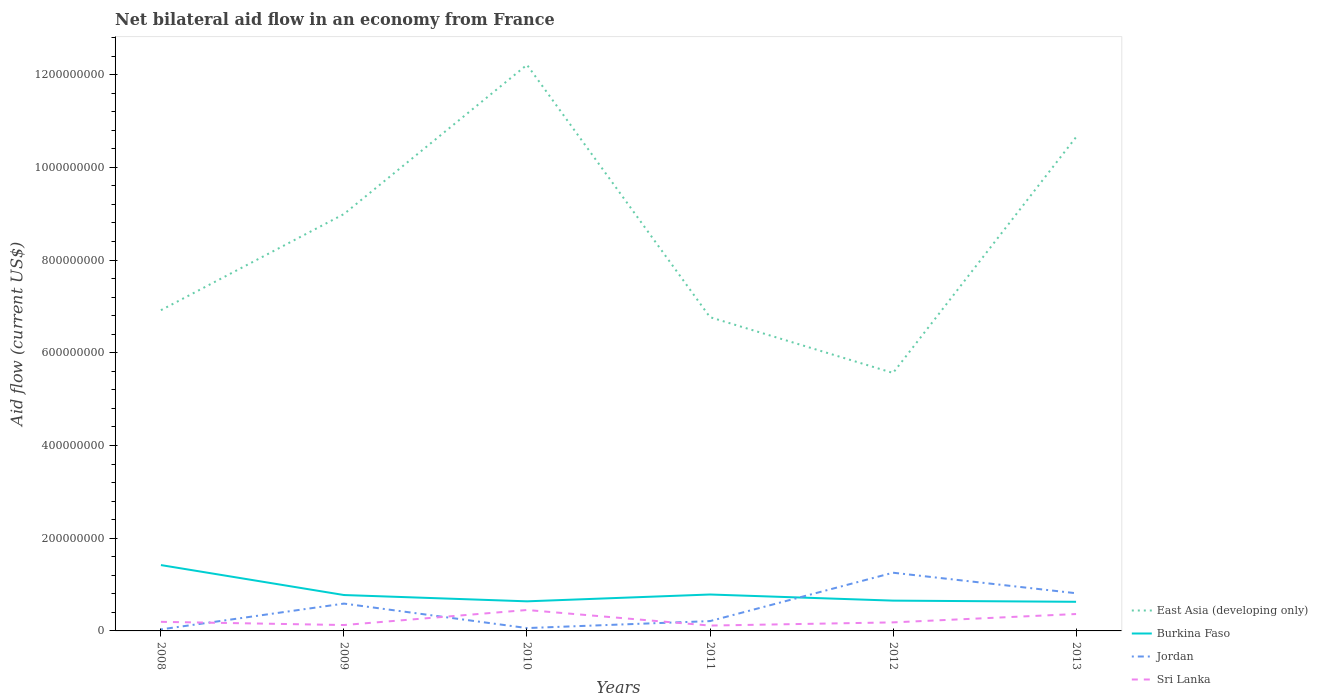Is the number of lines equal to the number of legend labels?
Offer a terse response. Yes. Across all years, what is the maximum net bilateral aid flow in East Asia (developing only)?
Offer a terse response. 5.56e+08. What is the total net bilateral aid flow in East Asia (developing only) in the graph?
Give a very brief answer. -5.29e+08. What is the difference between the highest and the second highest net bilateral aid flow in Sri Lanka?
Your answer should be very brief. 3.36e+07. What is the difference between two consecutive major ticks on the Y-axis?
Provide a succinct answer. 2.00e+08. Are the values on the major ticks of Y-axis written in scientific E-notation?
Your answer should be very brief. No. What is the title of the graph?
Provide a succinct answer. Net bilateral aid flow in an economy from France. Does "Kenya" appear as one of the legend labels in the graph?
Offer a terse response. No. What is the label or title of the Y-axis?
Provide a succinct answer. Aid flow (current US$). What is the Aid flow (current US$) of East Asia (developing only) in 2008?
Offer a terse response. 6.92e+08. What is the Aid flow (current US$) of Burkina Faso in 2008?
Give a very brief answer. 1.42e+08. What is the Aid flow (current US$) in Jordan in 2008?
Keep it short and to the point. 3.32e+06. What is the Aid flow (current US$) in Sri Lanka in 2008?
Make the answer very short. 1.96e+07. What is the Aid flow (current US$) of East Asia (developing only) in 2009?
Provide a short and direct response. 8.99e+08. What is the Aid flow (current US$) in Burkina Faso in 2009?
Offer a very short reply. 7.74e+07. What is the Aid flow (current US$) in Jordan in 2009?
Provide a short and direct response. 5.89e+07. What is the Aid flow (current US$) of Sri Lanka in 2009?
Provide a short and direct response. 1.27e+07. What is the Aid flow (current US$) of East Asia (developing only) in 2010?
Keep it short and to the point. 1.22e+09. What is the Aid flow (current US$) of Burkina Faso in 2010?
Your answer should be very brief. 6.38e+07. What is the Aid flow (current US$) of Jordan in 2010?
Give a very brief answer. 6.16e+06. What is the Aid flow (current US$) of Sri Lanka in 2010?
Offer a terse response. 4.51e+07. What is the Aid flow (current US$) in East Asia (developing only) in 2011?
Give a very brief answer. 6.77e+08. What is the Aid flow (current US$) in Burkina Faso in 2011?
Provide a short and direct response. 7.85e+07. What is the Aid flow (current US$) of Jordan in 2011?
Provide a succinct answer. 2.12e+07. What is the Aid flow (current US$) in Sri Lanka in 2011?
Your answer should be very brief. 1.15e+07. What is the Aid flow (current US$) in East Asia (developing only) in 2012?
Keep it short and to the point. 5.56e+08. What is the Aid flow (current US$) in Burkina Faso in 2012?
Your response must be concise. 6.53e+07. What is the Aid flow (current US$) of Jordan in 2012?
Make the answer very short. 1.26e+08. What is the Aid flow (current US$) of Sri Lanka in 2012?
Offer a very short reply. 1.84e+07. What is the Aid flow (current US$) of East Asia (developing only) in 2013?
Your answer should be compact. 1.07e+09. What is the Aid flow (current US$) of Burkina Faso in 2013?
Your answer should be very brief. 6.28e+07. What is the Aid flow (current US$) in Jordan in 2013?
Provide a short and direct response. 8.13e+07. What is the Aid flow (current US$) of Sri Lanka in 2013?
Provide a succinct answer. 3.64e+07. Across all years, what is the maximum Aid flow (current US$) in East Asia (developing only)?
Your response must be concise. 1.22e+09. Across all years, what is the maximum Aid flow (current US$) in Burkina Faso?
Ensure brevity in your answer.  1.42e+08. Across all years, what is the maximum Aid flow (current US$) of Jordan?
Your answer should be compact. 1.26e+08. Across all years, what is the maximum Aid flow (current US$) in Sri Lanka?
Your answer should be compact. 4.51e+07. Across all years, what is the minimum Aid flow (current US$) of East Asia (developing only)?
Provide a succinct answer. 5.56e+08. Across all years, what is the minimum Aid flow (current US$) of Burkina Faso?
Keep it short and to the point. 6.28e+07. Across all years, what is the minimum Aid flow (current US$) of Jordan?
Your response must be concise. 3.32e+06. Across all years, what is the minimum Aid flow (current US$) of Sri Lanka?
Offer a terse response. 1.15e+07. What is the total Aid flow (current US$) in East Asia (developing only) in the graph?
Provide a short and direct response. 5.11e+09. What is the total Aid flow (current US$) of Burkina Faso in the graph?
Your answer should be compact. 4.90e+08. What is the total Aid flow (current US$) in Jordan in the graph?
Provide a succinct answer. 2.96e+08. What is the total Aid flow (current US$) in Sri Lanka in the graph?
Provide a short and direct response. 1.44e+08. What is the difference between the Aid flow (current US$) in East Asia (developing only) in 2008 and that in 2009?
Provide a short and direct response. -2.07e+08. What is the difference between the Aid flow (current US$) in Burkina Faso in 2008 and that in 2009?
Offer a terse response. 6.46e+07. What is the difference between the Aid flow (current US$) in Jordan in 2008 and that in 2009?
Your answer should be very brief. -5.56e+07. What is the difference between the Aid flow (current US$) in Sri Lanka in 2008 and that in 2009?
Give a very brief answer. 6.92e+06. What is the difference between the Aid flow (current US$) in East Asia (developing only) in 2008 and that in 2010?
Ensure brevity in your answer.  -5.29e+08. What is the difference between the Aid flow (current US$) in Burkina Faso in 2008 and that in 2010?
Make the answer very short. 7.82e+07. What is the difference between the Aid flow (current US$) in Jordan in 2008 and that in 2010?
Provide a short and direct response. -2.84e+06. What is the difference between the Aid flow (current US$) of Sri Lanka in 2008 and that in 2010?
Give a very brief answer. -2.55e+07. What is the difference between the Aid flow (current US$) of East Asia (developing only) in 2008 and that in 2011?
Provide a succinct answer. 1.51e+07. What is the difference between the Aid flow (current US$) in Burkina Faso in 2008 and that in 2011?
Provide a succinct answer. 6.35e+07. What is the difference between the Aid flow (current US$) of Jordan in 2008 and that in 2011?
Keep it short and to the point. -1.79e+07. What is the difference between the Aid flow (current US$) of Sri Lanka in 2008 and that in 2011?
Your response must be concise. 8.07e+06. What is the difference between the Aid flow (current US$) of East Asia (developing only) in 2008 and that in 2012?
Offer a very short reply. 1.35e+08. What is the difference between the Aid flow (current US$) of Burkina Faso in 2008 and that in 2012?
Offer a terse response. 7.67e+07. What is the difference between the Aid flow (current US$) of Jordan in 2008 and that in 2012?
Your response must be concise. -1.22e+08. What is the difference between the Aid flow (current US$) in Sri Lanka in 2008 and that in 2012?
Offer a terse response. 1.19e+06. What is the difference between the Aid flow (current US$) of East Asia (developing only) in 2008 and that in 2013?
Make the answer very short. -3.73e+08. What is the difference between the Aid flow (current US$) in Burkina Faso in 2008 and that in 2013?
Ensure brevity in your answer.  7.92e+07. What is the difference between the Aid flow (current US$) in Jordan in 2008 and that in 2013?
Your response must be concise. -7.80e+07. What is the difference between the Aid flow (current US$) of Sri Lanka in 2008 and that in 2013?
Give a very brief answer. -1.68e+07. What is the difference between the Aid flow (current US$) of East Asia (developing only) in 2009 and that in 2010?
Provide a succinct answer. -3.22e+08. What is the difference between the Aid flow (current US$) in Burkina Faso in 2009 and that in 2010?
Your answer should be compact. 1.36e+07. What is the difference between the Aid flow (current US$) of Jordan in 2009 and that in 2010?
Make the answer very short. 5.28e+07. What is the difference between the Aid flow (current US$) of Sri Lanka in 2009 and that in 2010?
Provide a short and direct response. -3.24e+07. What is the difference between the Aid flow (current US$) of East Asia (developing only) in 2009 and that in 2011?
Make the answer very short. 2.22e+08. What is the difference between the Aid flow (current US$) of Burkina Faso in 2009 and that in 2011?
Keep it short and to the point. -1.12e+06. What is the difference between the Aid flow (current US$) in Jordan in 2009 and that in 2011?
Your response must be concise. 3.78e+07. What is the difference between the Aid flow (current US$) in Sri Lanka in 2009 and that in 2011?
Give a very brief answer. 1.15e+06. What is the difference between the Aid flow (current US$) in East Asia (developing only) in 2009 and that in 2012?
Ensure brevity in your answer.  3.43e+08. What is the difference between the Aid flow (current US$) in Burkina Faso in 2009 and that in 2012?
Offer a very short reply. 1.21e+07. What is the difference between the Aid flow (current US$) of Jordan in 2009 and that in 2012?
Offer a terse response. -6.66e+07. What is the difference between the Aid flow (current US$) of Sri Lanka in 2009 and that in 2012?
Make the answer very short. -5.73e+06. What is the difference between the Aid flow (current US$) in East Asia (developing only) in 2009 and that in 2013?
Offer a terse response. -1.66e+08. What is the difference between the Aid flow (current US$) in Burkina Faso in 2009 and that in 2013?
Your response must be concise. 1.46e+07. What is the difference between the Aid flow (current US$) of Jordan in 2009 and that in 2013?
Ensure brevity in your answer.  -2.24e+07. What is the difference between the Aid flow (current US$) in Sri Lanka in 2009 and that in 2013?
Make the answer very short. -2.38e+07. What is the difference between the Aid flow (current US$) of East Asia (developing only) in 2010 and that in 2011?
Provide a short and direct response. 5.44e+08. What is the difference between the Aid flow (current US$) in Burkina Faso in 2010 and that in 2011?
Your answer should be compact. -1.47e+07. What is the difference between the Aid flow (current US$) of Jordan in 2010 and that in 2011?
Offer a very short reply. -1.50e+07. What is the difference between the Aid flow (current US$) in Sri Lanka in 2010 and that in 2011?
Provide a succinct answer. 3.36e+07. What is the difference between the Aid flow (current US$) of East Asia (developing only) in 2010 and that in 2012?
Provide a short and direct response. 6.65e+08. What is the difference between the Aid flow (current US$) of Burkina Faso in 2010 and that in 2012?
Your answer should be compact. -1.51e+06. What is the difference between the Aid flow (current US$) in Jordan in 2010 and that in 2012?
Your answer should be very brief. -1.19e+08. What is the difference between the Aid flow (current US$) in Sri Lanka in 2010 and that in 2012?
Keep it short and to the point. 2.67e+07. What is the difference between the Aid flow (current US$) in East Asia (developing only) in 2010 and that in 2013?
Your response must be concise. 1.56e+08. What is the difference between the Aid flow (current US$) in Burkina Faso in 2010 and that in 2013?
Your answer should be very brief. 1.01e+06. What is the difference between the Aid flow (current US$) of Jordan in 2010 and that in 2013?
Make the answer very short. -7.51e+07. What is the difference between the Aid flow (current US$) of Sri Lanka in 2010 and that in 2013?
Provide a succinct answer. 8.69e+06. What is the difference between the Aid flow (current US$) of East Asia (developing only) in 2011 and that in 2012?
Give a very brief answer. 1.20e+08. What is the difference between the Aid flow (current US$) of Burkina Faso in 2011 and that in 2012?
Ensure brevity in your answer.  1.32e+07. What is the difference between the Aid flow (current US$) in Jordan in 2011 and that in 2012?
Make the answer very short. -1.04e+08. What is the difference between the Aid flow (current US$) in Sri Lanka in 2011 and that in 2012?
Provide a succinct answer. -6.88e+06. What is the difference between the Aid flow (current US$) of East Asia (developing only) in 2011 and that in 2013?
Your response must be concise. -3.88e+08. What is the difference between the Aid flow (current US$) in Burkina Faso in 2011 and that in 2013?
Offer a terse response. 1.57e+07. What is the difference between the Aid flow (current US$) of Jordan in 2011 and that in 2013?
Provide a short and direct response. -6.01e+07. What is the difference between the Aid flow (current US$) in Sri Lanka in 2011 and that in 2013?
Give a very brief answer. -2.49e+07. What is the difference between the Aid flow (current US$) of East Asia (developing only) in 2012 and that in 2013?
Your answer should be very brief. -5.09e+08. What is the difference between the Aid flow (current US$) of Burkina Faso in 2012 and that in 2013?
Ensure brevity in your answer.  2.52e+06. What is the difference between the Aid flow (current US$) of Jordan in 2012 and that in 2013?
Provide a short and direct response. 4.42e+07. What is the difference between the Aid flow (current US$) of Sri Lanka in 2012 and that in 2013?
Your answer should be compact. -1.80e+07. What is the difference between the Aid flow (current US$) in East Asia (developing only) in 2008 and the Aid flow (current US$) in Burkina Faso in 2009?
Ensure brevity in your answer.  6.14e+08. What is the difference between the Aid flow (current US$) of East Asia (developing only) in 2008 and the Aid flow (current US$) of Jordan in 2009?
Your answer should be compact. 6.33e+08. What is the difference between the Aid flow (current US$) in East Asia (developing only) in 2008 and the Aid flow (current US$) in Sri Lanka in 2009?
Offer a very short reply. 6.79e+08. What is the difference between the Aid flow (current US$) in Burkina Faso in 2008 and the Aid flow (current US$) in Jordan in 2009?
Make the answer very short. 8.31e+07. What is the difference between the Aid flow (current US$) in Burkina Faso in 2008 and the Aid flow (current US$) in Sri Lanka in 2009?
Provide a short and direct response. 1.29e+08. What is the difference between the Aid flow (current US$) in Jordan in 2008 and the Aid flow (current US$) in Sri Lanka in 2009?
Ensure brevity in your answer.  -9.37e+06. What is the difference between the Aid flow (current US$) in East Asia (developing only) in 2008 and the Aid flow (current US$) in Burkina Faso in 2010?
Your answer should be very brief. 6.28e+08. What is the difference between the Aid flow (current US$) of East Asia (developing only) in 2008 and the Aid flow (current US$) of Jordan in 2010?
Provide a short and direct response. 6.86e+08. What is the difference between the Aid flow (current US$) in East Asia (developing only) in 2008 and the Aid flow (current US$) in Sri Lanka in 2010?
Make the answer very short. 6.47e+08. What is the difference between the Aid flow (current US$) of Burkina Faso in 2008 and the Aid flow (current US$) of Jordan in 2010?
Your answer should be compact. 1.36e+08. What is the difference between the Aid flow (current US$) in Burkina Faso in 2008 and the Aid flow (current US$) in Sri Lanka in 2010?
Your response must be concise. 9.69e+07. What is the difference between the Aid flow (current US$) of Jordan in 2008 and the Aid flow (current US$) of Sri Lanka in 2010?
Ensure brevity in your answer.  -4.18e+07. What is the difference between the Aid flow (current US$) in East Asia (developing only) in 2008 and the Aid flow (current US$) in Burkina Faso in 2011?
Make the answer very short. 6.13e+08. What is the difference between the Aid flow (current US$) in East Asia (developing only) in 2008 and the Aid flow (current US$) in Jordan in 2011?
Offer a terse response. 6.71e+08. What is the difference between the Aid flow (current US$) of East Asia (developing only) in 2008 and the Aid flow (current US$) of Sri Lanka in 2011?
Your response must be concise. 6.80e+08. What is the difference between the Aid flow (current US$) of Burkina Faso in 2008 and the Aid flow (current US$) of Jordan in 2011?
Offer a terse response. 1.21e+08. What is the difference between the Aid flow (current US$) in Burkina Faso in 2008 and the Aid flow (current US$) in Sri Lanka in 2011?
Give a very brief answer. 1.30e+08. What is the difference between the Aid flow (current US$) of Jordan in 2008 and the Aid flow (current US$) of Sri Lanka in 2011?
Your answer should be very brief. -8.22e+06. What is the difference between the Aid flow (current US$) of East Asia (developing only) in 2008 and the Aid flow (current US$) of Burkina Faso in 2012?
Provide a short and direct response. 6.26e+08. What is the difference between the Aid flow (current US$) in East Asia (developing only) in 2008 and the Aid flow (current US$) in Jordan in 2012?
Offer a very short reply. 5.66e+08. What is the difference between the Aid flow (current US$) in East Asia (developing only) in 2008 and the Aid flow (current US$) in Sri Lanka in 2012?
Your answer should be compact. 6.73e+08. What is the difference between the Aid flow (current US$) of Burkina Faso in 2008 and the Aid flow (current US$) of Jordan in 2012?
Ensure brevity in your answer.  1.65e+07. What is the difference between the Aid flow (current US$) of Burkina Faso in 2008 and the Aid flow (current US$) of Sri Lanka in 2012?
Keep it short and to the point. 1.24e+08. What is the difference between the Aid flow (current US$) in Jordan in 2008 and the Aid flow (current US$) in Sri Lanka in 2012?
Make the answer very short. -1.51e+07. What is the difference between the Aid flow (current US$) of East Asia (developing only) in 2008 and the Aid flow (current US$) of Burkina Faso in 2013?
Provide a short and direct response. 6.29e+08. What is the difference between the Aid flow (current US$) in East Asia (developing only) in 2008 and the Aid flow (current US$) in Jordan in 2013?
Give a very brief answer. 6.10e+08. What is the difference between the Aid flow (current US$) in East Asia (developing only) in 2008 and the Aid flow (current US$) in Sri Lanka in 2013?
Ensure brevity in your answer.  6.55e+08. What is the difference between the Aid flow (current US$) of Burkina Faso in 2008 and the Aid flow (current US$) of Jordan in 2013?
Give a very brief answer. 6.07e+07. What is the difference between the Aid flow (current US$) in Burkina Faso in 2008 and the Aid flow (current US$) in Sri Lanka in 2013?
Ensure brevity in your answer.  1.06e+08. What is the difference between the Aid flow (current US$) of Jordan in 2008 and the Aid flow (current US$) of Sri Lanka in 2013?
Offer a terse response. -3.31e+07. What is the difference between the Aid flow (current US$) of East Asia (developing only) in 2009 and the Aid flow (current US$) of Burkina Faso in 2010?
Offer a very short reply. 8.35e+08. What is the difference between the Aid flow (current US$) of East Asia (developing only) in 2009 and the Aid flow (current US$) of Jordan in 2010?
Your answer should be very brief. 8.93e+08. What is the difference between the Aid flow (current US$) of East Asia (developing only) in 2009 and the Aid flow (current US$) of Sri Lanka in 2010?
Offer a very short reply. 8.54e+08. What is the difference between the Aid flow (current US$) of Burkina Faso in 2009 and the Aid flow (current US$) of Jordan in 2010?
Make the answer very short. 7.13e+07. What is the difference between the Aid flow (current US$) of Burkina Faso in 2009 and the Aid flow (current US$) of Sri Lanka in 2010?
Give a very brief answer. 3.23e+07. What is the difference between the Aid flow (current US$) in Jordan in 2009 and the Aid flow (current US$) in Sri Lanka in 2010?
Offer a very short reply. 1.38e+07. What is the difference between the Aid flow (current US$) of East Asia (developing only) in 2009 and the Aid flow (current US$) of Burkina Faso in 2011?
Offer a very short reply. 8.21e+08. What is the difference between the Aid flow (current US$) of East Asia (developing only) in 2009 and the Aid flow (current US$) of Jordan in 2011?
Provide a short and direct response. 8.78e+08. What is the difference between the Aid flow (current US$) of East Asia (developing only) in 2009 and the Aid flow (current US$) of Sri Lanka in 2011?
Ensure brevity in your answer.  8.88e+08. What is the difference between the Aid flow (current US$) of Burkina Faso in 2009 and the Aid flow (current US$) of Jordan in 2011?
Keep it short and to the point. 5.62e+07. What is the difference between the Aid flow (current US$) in Burkina Faso in 2009 and the Aid flow (current US$) in Sri Lanka in 2011?
Give a very brief answer. 6.59e+07. What is the difference between the Aid flow (current US$) in Jordan in 2009 and the Aid flow (current US$) in Sri Lanka in 2011?
Your response must be concise. 4.74e+07. What is the difference between the Aid flow (current US$) in East Asia (developing only) in 2009 and the Aid flow (current US$) in Burkina Faso in 2012?
Ensure brevity in your answer.  8.34e+08. What is the difference between the Aid flow (current US$) of East Asia (developing only) in 2009 and the Aid flow (current US$) of Jordan in 2012?
Provide a short and direct response. 7.74e+08. What is the difference between the Aid flow (current US$) of East Asia (developing only) in 2009 and the Aid flow (current US$) of Sri Lanka in 2012?
Give a very brief answer. 8.81e+08. What is the difference between the Aid flow (current US$) in Burkina Faso in 2009 and the Aid flow (current US$) in Jordan in 2012?
Keep it short and to the point. -4.81e+07. What is the difference between the Aid flow (current US$) of Burkina Faso in 2009 and the Aid flow (current US$) of Sri Lanka in 2012?
Give a very brief answer. 5.90e+07. What is the difference between the Aid flow (current US$) of Jordan in 2009 and the Aid flow (current US$) of Sri Lanka in 2012?
Give a very brief answer. 4.05e+07. What is the difference between the Aid flow (current US$) in East Asia (developing only) in 2009 and the Aid flow (current US$) in Burkina Faso in 2013?
Your response must be concise. 8.36e+08. What is the difference between the Aid flow (current US$) of East Asia (developing only) in 2009 and the Aid flow (current US$) of Jordan in 2013?
Provide a short and direct response. 8.18e+08. What is the difference between the Aid flow (current US$) of East Asia (developing only) in 2009 and the Aid flow (current US$) of Sri Lanka in 2013?
Offer a very short reply. 8.63e+08. What is the difference between the Aid flow (current US$) in Burkina Faso in 2009 and the Aid flow (current US$) in Jordan in 2013?
Provide a succinct answer. -3.87e+06. What is the difference between the Aid flow (current US$) of Burkina Faso in 2009 and the Aid flow (current US$) of Sri Lanka in 2013?
Give a very brief answer. 4.10e+07. What is the difference between the Aid flow (current US$) of Jordan in 2009 and the Aid flow (current US$) of Sri Lanka in 2013?
Keep it short and to the point. 2.25e+07. What is the difference between the Aid flow (current US$) of East Asia (developing only) in 2010 and the Aid flow (current US$) of Burkina Faso in 2011?
Your response must be concise. 1.14e+09. What is the difference between the Aid flow (current US$) in East Asia (developing only) in 2010 and the Aid flow (current US$) in Jordan in 2011?
Provide a succinct answer. 1.20e+09. What is the difference between the Aid flow (current US$) of East Asia (developing only) in 2010 and the Aid flow (current US$) of Sri Lanka in 2011?
Your response must be concise. 1.21e+09. What is the difference between the Aid flow (current US$) in Burkina Faso in 2010 and the Aid flow (current US$) in Jordan in 2011?
Offer a terse response. 4.26e+07. What is the difference between the Aid flow (current US$) in Burkina Faso in 2010 and the Aid flow (current US$) in Sri Lanka in 2011?
Keep it short and to the point. 5.23e+07. What is the difference between the Aid flow (current US$) in Jordan in 2010 and the Aid flow (current US$) in Sri Lanka in 2011?
Give a very brief answer. -5.38e+06. What is the difference between the Aid flow (current US$) of East Asia (developing only) in 2010 and the Aid flow (current US$) of Burkina Faso in 2012?
Your answer should be compact. 1.16e+09. What is the difference between the Aid flow (current US$) of East Asia (developing only) in 2010 and the Aid flow (current US$) of Jordan in 2012?
Provide a succinct answer. 1.10e+09. What is the difference between the Aid flow (current US$) of East Asia (developing only) in 2010 and the Aid flow (current US$) of Sri Lanka in 2012?
Your answer should be compact. 1.20e+09. What is the difference between the Aid flow (current US$) in Burkina Faso in 2010 and the Aid flow (current US$) in Jordan in 2012?
Give a very brief answer. -6.17e+07. What is the difference between the Aid flow (current US$) of Burkina Faso in 2010 and the Aid flow (current US$) of Sri Lanka in 2012?
Your response must be concise. 4.54e+07. What is the difference between the Aid flow (current US$) of Jordan in 2010 and the Aid flow (current US$) of Sri Lanka in 2012?
Your response must be concise. -1.23e+07. What is the difference between the Aid flow (current US$) in East Asia (developing only) in 2010 and the Aid flow (current US$) in Burkina Faso in 2013?
Your answer should be very brief. 1.16e+09. What is the difference between the Aid flow (current US$) in East Asia (developing only) in 2010 and the Aid flow (current US$) in Jordan in 2013?
Offer a very short reply. 1.14e+09. What is the difference between the Aid flow (current US$) in East Asia (developing only) in 2010 and the Aid flow (current US$) in Sri Lanka in 2013?
Keep it short and to the point. 1.18e+09. What is the difference between the Aid flow (current US$) in Burkina Faso in 2010 and the Aid flow (current US$) in Jordan in 2013?
Offer a terse response. -1.75e+07. What is the difference between the Aid flow (current US$) in Burkina Faso in 2010 and the Aid flow (current US$) in Sri Lanka in 2013?
Keep it short and to the point. 2.74e+07. What is the difference between the Aid flow (current US$) in Jordan in 2010 and the Aid flow (current US$) in Sri Lanka in 2013?
Offer a terse response. -3.03e+07. What is the difference between the Aid flow (current US$) of East Asia (developing only) in 2011 and the Aid flow (current US$) of Burkina Faso in 2012?
Make the answer very short. 6.11e+08. What is the difference between the Aid flow (current US$) in East Asia (developing only) in 2011 and the Aid flow (current US$) in Jordan in 2012?
Ensure brevity in your answer.  5.51e+08. What is the difference between the Aid flow (current US$) of East Asia (developing only) in 2011 and the Aid flow (current US$) of Sri Lanka in 2012?
Your response must be concise. 6.58e+08. What is the difference between the Aid flow (current US$) in Burkina Faso in 2011 and the Aid flow (current US$) in Jordan in 2012?
Your answer should be very brief. -4.70e+07. What is the difference between the Aid flow (current US$) of Burkina Faso in 2011 and the Aid flow (current US$) of Sri Lanka in 2012?
Your answer should be very brief. 6.01e+07. What is the difference between the Aid flow (current US$) in Jordan in 2011 and the Aid flow (current US$) in Sri Lanka in 2012?
Provide a succinct answer. 2.76e+06. What is the difference between the Aid flow (current US$) in East Asia (developing only) in 2011 and the Aid flow (current US$) in Burkina Faso in 2013?
Your answer should be compact. 6.14e+08. What is the difference between the Aid flow (current US$) of East Asia (developing only) in 2011 and the Aid flow (current US$) of Jordan in 2013?
Offer a very short reply. 5.95e+08. What is the difference between the Aid flow (current US$) in East Asia (developing only) in 2011 and the Aid flow (current US$) in Sri Lanka in 2013?
Make the answer very short. 6.40e+08. What is the difference between the Aid flow (current US$) in Burkina Faso in 2011 and the Aid flow (current US$) in Jordan in 2013?
Your answer should be very brief. -2.75e+06. What is the difference between the Aid flow (current US$) of Burkina Faso in 2011 and the Aid flow (current US$) of Sri Lanka in 2013?
Your response must be concise. 4.21e+07. What is the difference between the Aid flow (current US$) of Jordan in 2011 and the Aid flow (current US$) of Sri Lanka in 2013?
Offer a very short reply. -1.53e+07. What is the difference between the Aid flow (current US$) of East Asia (developing only) in 2012 and the Aid flow (current US$) of Burkina Faso in 2013?
Make the answer very short. 4.94e+08. What is the difference between the Aid flow (current US$) of East Asia (developing only) in 2012 and the Aid flow (current US$) of Jordan in 2013?
Your response must be concise. 4.75e+08. What is the difference between the Aid flow (current US$) in East Asia (developing only) in 2012 and the Aid flow (current US$) in Sri Lanka in 2013?
Provide a short and direct response. 5.20e+08. What is the difference between the Aid flow (current US$) in Burkina Faso in 2012 and the Aid flow (current US$) in Jordan in 2013?
Give a very brief answer. -1.60e+07. What is the difference between the Aid flow (current US$) of Burkina Faso in 2012 and the Aid flow (current US$) of Sri Lanka in 2013?
Make the answer very short. 2.89e+07. What is the difference between the Aid flow (current US$) of Jordan in 2012 and the Aid flow (current US$) of Sri Lanka in 2013?
Provide a succinct answer. 8.91e+07. What is the average Aid flow (current US$) of East Asia (developing only) per year?
Give a very brief answer. 8.52e+08. What is the average Aid flow (current US$) in Burkina Faso per year?
Provide a short and direct response. 8.17e+07. What is the average Aid flow (current US$) of Jordan per year?
Your response must be concise. 4.94e+07. What is the average Aid flow (current US$) in Sri Lanka per year?
Your answer should be compact. 2.40e+07. In the year 2008, what is the difference between the Aid flow (current US$) of East Asia (developing only) and Aid flow (current US$) of Burkina Faso?
Give a very brief answer. 5.50e+08. In the year 2008, what is the difference between the Aid flow (current US$) of East Asia (developing only) and Aid flow (current US$) of Jordan?
Offer a terse response. 6.88e+08. In the year 2008, what is the difference between the Aid flow (current US$) of East Asia (developing only) and Aid flow (current US$) of Sri Lanka?
Ensure brevity in your answer.  6.72e+08. In the year 2008, what is the difference between the Aid flow (current US$) of Burkina Faso and Aid flow (current US$) of Jordan?
Your answer should be very brief. 1.39e+08. In the year 2008, what is the difference between the Aid flow (current US$) of Burkina Faso and Aid flow (current US$) of Sri Lanka?
Offer a terse response. 1.22e+08. In the year 2008, what is the difference between the Aid flow (current US$) in Jordan and Aid flow (current US$) in Sri Lanka?
Offer a terse response. -1.63e+07. In the year 2009, what is the difference between the Aid flow (current US$) in East Asia (developing only) and Aid flow (current US$) in Burkina Faso?
Ensure brevity in your answer.  8.22e+08. In the year 2009, what is the difference between the Aid flow (current US$) of East Asia (developing only) and Aid flow (current US$) of Jordan?
Offer a very short reply. 8.40e+08. In the year 2009, what is the difference between the Aid flow (current US$) in East Asia (developing only) and Aid flow (current US$) in Sri Lanka?
Keep it short and to the point. 8.86e+08. In the year 2009, what is the difference between the Aid flow (current US$) of Burkina Faso and Aid flow (current US$) of Jordan?
Your answer should be very brief. 1.85e+07. In the year 2009, what is the difference between the Aid flow (current US$) in Burkina Faso and Aid flow (current US$) in Sri Lanka?
Offer a terse response. 6.47e+07. In the year 2009, what is the difference between the Aid flow (current US$) in Jordan and Aid flow (current US$) in Sri Lanka?
Your answer should be very brief. 4.62e+07. In the year 2010, what is the difference between the Aid flow (current US$) in East Asia (developing only) and Aid flow (current US$) in Burkina Faso?
Your answer should be very brief. 1.16e+09. In the year 2010, what is the difference between the Aid flow (current US$) in East Asia (developing only) and Aid flow (current US$) in Jordan?
Offer a terse response. 1.21e+09. In the year 2010, what is the difference between the Aid flow (current US$) in East Asia (developing only) and Aid flow (current US$) in Sri Lanka?
Your answer should be compact. 1.18e+09. In the year 2010, what is the difference between the Aid flow (current US$) in Burkina Faso and Aid flow (current US$) in Jordan?
Keep it short and to the point. 5.77e+07. In the year 2010, what is the difference between the Aid flow (current US$) of Burkina Faso and Aid flow (current US$) of Sri Lanka?
Ensure brevity in your answer.  1.87e+07. In the year 2010, what is the difference between the Aid flow (current US$) of Jordan and Aid flow (current US$) of Sri Lanka?
Provide a short and direct response. -3.90e+07. In the year 2011, what is the difference between the Aid flow (current US$) in East Asia (developing only) and Aid flow (current US$) in Burkina Faso?
Your answer should be very brief. 5.98e+08. In the year 2011, what is the difference between the Aid flow (current US$) of East Asia (developing only) and Aid flow (current US$) of Jordan?
Keep it short and to the point. 6.55e+08. In the year 2011, what is the difference between the Aid flow (current US$) of East Asia (developing only) and Aid flow (current US$) of Sri Lanka?
Offer a terse response. 6.65e+08. In the year 2011, what is the difference between the Aid flow (current US$) of Burkina Faso and Aid flow (current US$) of Jordan?
Keep it short and to the point. 5.74e+07. In the year 2011, what is the difference between the Aid flow (current US$) of Burkina Faso and Aid flow (current US$) of Sri Lanka?
Ensure brevity in your answer.  6.70e+07. In the year 2011, what is the difference between the Aid flow (current US$) of Jordan and Aid flow (current US$) of Sri Lanka?
Your answer should be compact. 9.64e+06. In the year 2012, what is the difference between the Aid flow (current US$) of East Asia (developing only) and Aid flow (current US$) of Burkina Faso?
Provide a short and direct response. 4.91e+08. In the year 2012, what is the difference between the Aid flow (current US$) in East Asia (developing only) and Aid flow (current US$) in Jordan?
Keep it short and to the point. 4.31e+08. In the year 2012, what is the difference between the Aid flow (current US$) in East Asia (developing only) and Aid flow (current US$) in Sri Lanka?
Give a very brief answer. 5.38e+08. In the year 2012, what is the difference between the Aid flow (current US$) in Burkina Faso and Aid flow (current US$) in Jordan?
Offer a very short reply. -6.02e+07. In the year 2012, what is the difference between the Aid flow (current US$) of Burkina Faso and Aid flow (current US$) of Sri Lanka?
Offer a very short reply. 4.69e+07. In the year 2012, what is the difference between the Aid flow (current US$) in Jordan and Aid flow (current US$) in Sri Lanka?
Provide a short and direct response. 1.07e+08. In the year 2013, what is the difference between the Aid flow (current US$) of East Asia (developing only) and Aid flow (current US$) of Burkina Faso?
Your answer should be compact. 1.00e+09. In the year 2013, what is the difference between the Aid flow (current US$) in East Asia (developing only) and Aid flow (current US$) in Jordan?
Give a very brief answer. 9.84e+08. In the year 2013, what is the difference between the Aid flow (current US$) of East Asia (developing only) and Aid flow (current US$) of Sri Lanka?
Make the answer very short. 1.03e+09. In the year 2013, what is the difference between the Aid flow (current US$) in Burkina Faso and Aid flow (current US$) in Jordan?
Give a very brief answer. -1.85e+07. In the year 2013, what is the difference between the Aid flow (current US$) of Burkina Faso and Aid flow (current US$) of Sri Lanka?
Your answer should be very brief. 2.64e+07. In the year 2013, what is the difference between the Aid flow (current US$) of Jordan and Aid flow (current US$) of Sri Lanka?
Offer a very short reply. 4.48e+07. What is the ratio of the Aid flow (current US$) in East Asia (developing only) in 2008 to that in 2009?
Offer a very short reply. 0.77. What is the ratio of the Aid flow (current US$) in Burkina Faso in 2008 to that in 2009?
Keep it short and to the point. 1.83. What is the ratio of the Aid flow (current US$) in Jordan in 2008 to that in 2009?
Make the answer very short. 0.06. What is the ratio of the Aid flow (current US$) of Sri Lanka in 2008 to that in 2009?
Give a very brief answer. 1.55. What is the ratio of the Aid flow (current US$) of East Asia (developing only) in 2008 to that in 2010?
Provide a succinct answer. 0.57. What is the ratio of the Aid flow (current US$) in Burkina Faso in 2008 to that in 2010?
Ensure brevity in your answer.  2.22. What is the ratio of the Aid flow (current US$) in Jordan in 2008 to that in 2010?
Give a very brief answer. 0.54. What is the ratio of the Aid flow (current US$) in Sri Lanka in 2008 to that in 2010?
Make the answer very short. 0.43. What is the ratio of the Aid flow (current US$) of East Asia (developing only) in 2008 to that in 2011?
Offer a terse response. 1.02. What is the ratio of the Aid flow (current US$) of Burkina Faso in 2008 to that in 2011?
Offer a terse response. 1.81. What is the ratio of the Aid flow (current US$) of Jordan in 2008 to that in 2011?
Your answer should be very brief. 0.16. What is the ratio of the Aid flow (current US$) of Sri Lanka in 2008 to that in 2011?
Make the answer very short. 1.7. What is the ratio of the Aid flow (current US$) in East Asia (developing only) in 2008 to that in 2012?
Provide a succinct answer. 1.24. What is the ratio of the Aid flow (current US$) of Burkina Faso in 2008 to that in 2012?
Make the answer very short. 2.17. What is the ratio of the Aid flow (current US$) in Jordan in 2008 to that in 2012?
Your answer should be very brief. 0.03. What is the ratio of the Aid flow (current US$) of Sri Lanka in 2008 to that in 2012?
Keep it short and to the point. 1.06. What is the ratio of the Aid flow (current US$) in East Asia (developing only) in 2008 to that in 2013?
Provide a short and direct response. 0.65. What is the ratio of the Aid flow (current US$) in Burkina Faso in 2008 to that in 2013?
Ensure brevity in your answer.  2.26. What is the ratio of the Aid flow (current US$) in Jordan in 2008 to that in 2013?
Your answer should be compact. 0.04. What is the ratio of the Aid flow (current US$) in Sri Lanka in 2008 to that in 2013?
Offer a very short reply. 0.54. What is the ratio of the Aid flow (current US$) of East Asia (developing only) in 2009 to that in 2010?
Offer a very short reply. 0.74. What is the ratio of the Aid flow (current US$) of Burkina Faso in 2009 to that in 2010?
Your answer should be very brief. 1.21. What is the ratio of the Aid flow (current US$) in Jordan in 2009 to that in 2010?
Keep it short and to the point. 9.57. What is the ratio of the Aid flow (current US$) of Sri Lanka in 2009 to that in 2010?
Your answer should be very brief. 0.28. What is the ratio of the Aid flow (current US$) of East Asia (developing only) in 2009 to that in 2011?
Your answer should be very brief. 1.33. What is the ratio of the Aid flow (current US$) in Burkina Faso in 2009 to that in 2011?
Your answer should be very brief. 0.99. What is the ratio of the Aid flow (current US$) in Jordan in 2009 to that in 2011?
Offer a very short reply. 2.78. What is the ratio of the Aid flow (current US$) in Sri Lanka in 2009 to that in 2011?
Your response must be concise. 1.1. What is the ratio of the Aid flow (current US$) of East Asia (developing only) in 2009 to that in 2012?
Give a very brief answer. 1.62. What is the ratio of the Aid flow (current US$) in Burkina Faso in 2009 to that in 2012?
Give a very brief answer. 1.18. What is the ratio of the Aid flow (current US$) in Jordan in 2009 to that in 2012?
Keep it short and to the point. 0.47. What is the ratio of the Aid flow (current US$) of Sri Lanka in 2009 to that in 2012?
Provide a short and direct response. 0.69. What is the ratio of the Aid flow (current US$) in East Asia (developing only) in 2009 to that in 2013?
Provide a succinct answer. 0.84. What is the ratio of the Aid flow (current US$) in Burkina Faso in 2009 to that in 2013?
Make the answer very short. 1.23. What is the ratio of the Aid flow (current US$) of Jordan in 2009 to that in 2013?
Your response must be concise. 0.73. What is the ratio of the Aid flow (current US$) in Sri Lanka in 2009 to that in 2013?
Provide a short and direct response. 0.35. What is the ratio of the Aid flow (current US$) of East Asia (developing only) in 2010 to that in 2011?
Provide a succinct answer. 1.8. What is the ratio of the Aid flow (current US$) in Burkina Faso in 2010 to that in 2011?
Your answer should be compact. 0.81. What is the ratio of the Aid flow (current US$) of Jordan in 2010 to that in 2011?
Offer a terse response. 0.29. What is the ratio of the Aid flow (current US$) of Sri Lanka in 2010 to that in 2011?
Your answer should be compact. 3.91. What is the ratio of the Aid flow (current US$) of East Asia (developing only) in 2010 to that in 2012?
Provide a short and direct response. 2.19. What is the ratio of the Aid flow (current US$) of Burkina Faso in 2010 to that in 2012?
Your answer should be very brief. 0.98. What is the ratio of the Aid flow (current US$) of Jordan in 2010 to that in 2012?
Offer a terse response. 0.05. What is the ratio of the Aid flow (current US$) in Sri Lanka in 2010 to that in 2012?
Make the answer very short. 2.45. What is the ratio of the Aid flow (current US$) of East Asia (developing only) in 2010 to that in 2013?
Offer a terse response. 1.15. What is the ratio of the Aid flow (current US$) in Burkina Faso in 2010 to that in 2013?
Your answer should be compact. 1.02. What is the ratio of the Aid flow (current US$) in Jordan in 2010 to that in 2013?
Keep it short and to the point. 0.08. What is the ratio of the Aid flow (current US$) of Sri Lanka in 2010 to that in 2013?
Provide a succinct answer. 1.24. What is the ratio of the Aid flow (current US$) in East Asia (developing only) in 2011 to that in 2012?
Your response must be concise. 1.22. What is the ratio of the Aid flow (current US$) of Burkina Faso in 2011 to that in 2012?
Provide a short and direct response. 1.2. What is the ratio of the Aid flow (current US$) in Jordan in 2011 to that in 2012?
Your response must be concise. 0.17. What is the ratio of the Aid flow (current US$) in Sri Lanka in 2011 to that in 2012?
Your response must be concise. 0.63. What is the ratio of the Aid flow (current US$) in East Asia (developing only) in 2011 to that in 2013?
Offer a very short reply. 0.64. What is the ratio of the Aid flow (current US$) of Burkina Faso in 2011 to that in 2013?
Ensure brevity in your answer.  1.25. What is the ratio of the Aid flow (current US$) in Jordan in 2011 to that in 2013?
Your answer should be compact. 0.26. What is the ratio of the Aid flow (current US$) of Sri Lanka in 2011 to that in 2013?
Give a very brief answer. 0.32. What is the ratio of the Aid flow (current US$) in East Asia (developing only) in 2012 to that in 2013?
Provide a short and direct response. 0.52. What is the ratio of the Aid flow (current US$) in Burkina Faso in 2012 to that in 2013?
Make the answer very short. 1.04. What is the ratio of the Aid flow (current US$) in Jordan in 2012 to that in 2013?
Make the answer very short. 1.54. What is the ratio of the Aid flow (current US$) in Sri Lanka in 2012 to that in 2013?
Ensure brevity in your answer.  0.51. What is the difference between the highest and the second highest Aid flow (current US$) of East Asia (developing only)?
Ensure brevity in your answer.  1.56e+08. What is the difference between the highest and the second highest Aid flow (current US$) of Burkina Faso?
Your answer should be very brief. 6.35e+07. What is the difference between the highest and the second highest Aid flow (current US$) in Jordan?
Your answer should be very brief. 4.42e+07. What is the difference between the highest and the second highest Aid flow (current US$) in Sri Lanka?
Provide a short and direct response. 8.69e+06. What is the difference between the highest and the lowest Aid flow (current US$) of East Asia (developing only)?
Your response must be concise. 6.65e+08. What is the difference between the highest and the lowest Aid flow (current US$) of Burkina Faso?
Your response must be concise. 7.92e+07. What is the difference between the highest and the lowest Aid flow (current US$) in Jordan?
Your response must be concise. 1.22e+08. What is the difference between the highest and the lowest Aid flow (current US$) in Sri Lanka?
Provide a short and direct response. 3.36e+07. 